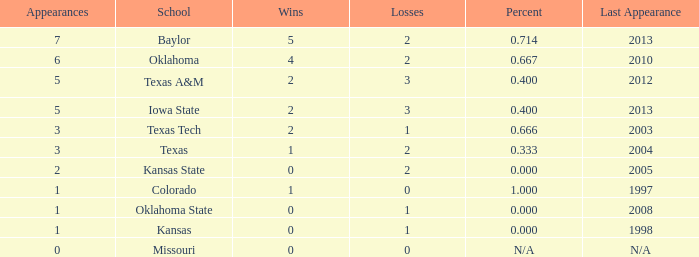What's the largest amount of wins Texas has?  1.0. 